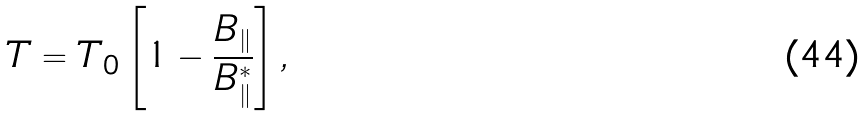Convert formula to latex. <formula><loc_0><loc_0><loc_500><loc_500>T = T _ { 0 } \left [ 1 - \frac { B _ { \| } } { B _ { \| } ^ { * } } \right ] ,</formula> 